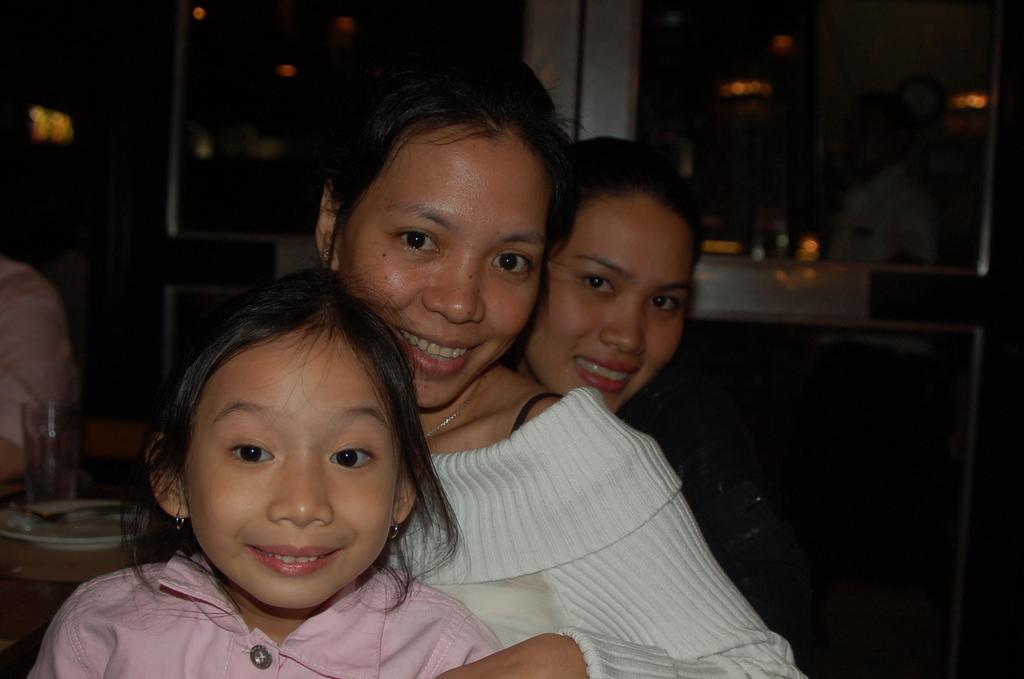Can you describe this image briefly? In this image we can see women sitting on the chair. In the background there are cupboards, serving plates, glass tumblers, cutlery, table and a person standing on the floor. 